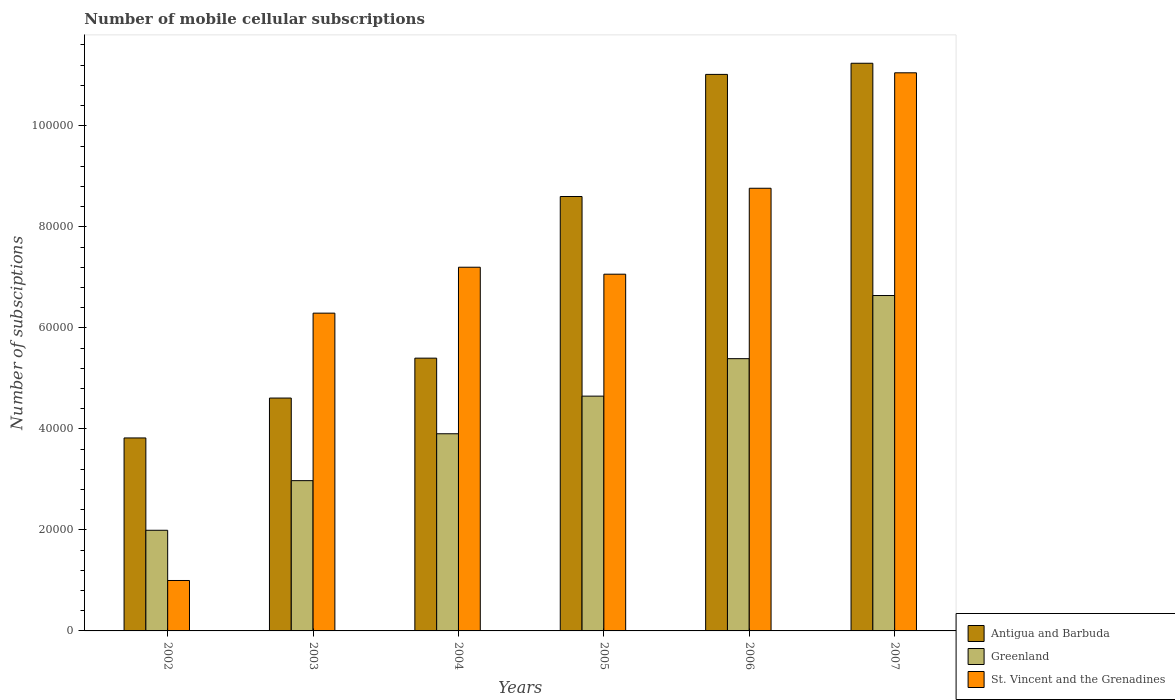How many different coloured bars are there?
Keep it short and to the point. 3. How many bars are there on the 4th tick from the right?
Offer a very short reply. 3. In how many cases, is the number of bars for a given year not equal to the number of legend labels?
Give a very brief answer. 0. What is the number of mobile cellular subscriptions in St. Vincent and the Grenadines in 2005?
Your answer should be very brief. 7.06e+04. Across all years, what is the maximum number of mobile cellular subscriptions in St. Vincent and the Grenadines?
Provide a succinct answer. 1.10e+05. Across all years, what is the minimum number of mobile cellular subscriptions in Greenland?
Your answer should be compact. 1.99e+04. In which year was the number of mobile cellular subscriptions in Antigua and Barbuda maximum?
Your answer should be very brief. 2007. What is the total number of mobile cellular subscriptions in Antigua and Barbuda in the graph?
Offer a very short reply. 4.47e+05. What is the difference between the number of mobile cellular subscriptions in Greenland in 2003 and that in 2004?
Make the answer very short. -9284. What is the difference between the number of mobile cellular subscriptions in Antigua and Barbuda in 2005 and the number of mobile cellular subscriptions in Greenland in 2002?
Offer a terse response. 6.61e+04. What is the average number of mobile cellular subscriptions in St. Vincent and the Grenadines per year?
Provide a succinct answer. 6.89e+04. In the year 2006, what is the difference between the number of mobile cellular subscriptions in St. Vincent and the Grenadines and number of mobile cellular subscriptions in Antigua and Barbuda?
Your answer should be compact. -2.25e+04. In how many years, is the number of mobile cellular subscriptions in St. Vincent and the Grenadines greater than 24000?
Your response must be concise. 5. What is the ratio of the number of mobile cellular subscriptions in St. Vincent and the Grenadines in 2002 to that in 2007?
Your answer should be very brief. 0.09. What is the difference between the highest and the second highest number of mobile cellular subscriptions in Greenland?
Provide a succinct answer. 1.25e+04. What is the difference between the highest and the lowest number of mobile cellular subscriptions in Greenland?
Provide a succinct answer. 4.65e+04. Is the sum of the number of mobile cellular subscriptions in Greenland in 2004 and 2007 greater than the maximum number of mobile cellular subscriptions in Antigua and Barbuda across all years?
Your answer should be compact. No. What does the 2nd bar from the left in 2007 represents?
Offer a terse response. Greenland. What does the 2nd bar from the right in 2004 represents?
Offer a very short reply. Greenland. Is it the case that in every year, the sum of the number of mobile cellular subscriptions in St. Vincent and the Grenadines and number of mobile cellular subscriptions in Antigua and Barbuda is greater than the number of mobile cellular subscriptions in Greenland?
Keep it short and to the point. Yes. Are all the bars in the graph horizontal?
Ensure brevity in your answer.  No. What is the difference between two consecutive major ticks on the Y-axis?
Your response must be concise. 2.00e+04. Are the values on the major ticks of Y-axis written in scientific E-notation?
Your answer should be very brief. No. Does the graph contain grids?
Provide a succinct answer. No. What is the title of the graph?
Your answer should be very brief. Number of mobile cellular subscriptions. Does "Cabo Verde" appear as one of the legend labels in the graph?
Offer a terse response. No. What is the label or title of the X-axis?
Offer a terse response. Years. What is the label or title of the Y-axis?
Keep it short and to the point. Number of subsciptions. What is the Number of subsciptions of Antigua and Barbuda in 2002?
Your answer should be very brief. 3.82e+04. What is the Number of subsciptions of Greenland in 2002?
Provide a short and direct response. 1.99e+04. What is the Number of subsciptions in St. Vincent and the Grenadines in 2002?
Provide a succinct answer. 9982. What is the Number of subsciptions in Antigua and Barbuda in 2003?
Offer a very short reply. 4.61e+04. What is the Number of subsciptions in Greenland in 2003?
Provide a succinct answer. 2.97e+04. What is the Number of subsciptions in St. Vincent and the Grenadines in 2003?
Your answer should be very brief. 6.29e+04. What is the Number of subsciptions in Antigua and Barbuda in 2004?
Make the answer very short. 5.40e+04. What is the Number of subsciptions of Greenland in 2004?
Your response must be concise. 3.90e+04. What is the Number of subsciptions of St. Vincent and the Grenadines in 2004?
Provide a short and direct response. 7.20e+04. What is the Number of subsciptions in Antigua and Barbuda in 2005?
Your answer should be very brief. 8.60e+04. What is the Number of subsciptions of Greenland in 2005?
Give a very brief answer. 4.65e+04. What is the Number of subsciptions in St. Vincent and the Grenadines in 2005?
Provide a succinct answer. 7.06e+04. What is the Number of subsciptions in Antigua and Barbuda in 2006?
Keep it short and to the point. 1.10e+05. What is the Number of subsciptions in Greenland in 2006?
Offer a very short reply. 5.39e+04. What is the Number of subsciptions in St. Vincent and the Grenadines in 2006?
Your answer should be compact. 8.76e+04. What is the Number of subsciptions of Antigua and Barbuda in 2007?
Your response must be concise. 1.12e+05. What is the Number of subsciptions of Greenland in 2007?
Ensure brevity in your answer.  6.64e+04. What is the Number of subsciptions of St. Vincent and the Grenadines in 2007?
Keep it short and to the point. 1.10e+05. Across all years, what is the maximum Number of subsciptions in Antigua and Barbuda?
Keep it short and to the point. 1.12e+05. Across all years, what is the maximum Number of subsciptions in Greenland?
Offer a terse response. 6.64e+04. Across all years, what is the maximum Number of subsciptions in St. Vincent and the Grenadines?
Your response must be concise. 1.10e+05. Across all years, what is the minimum Number of subsciptions in Antigua and Barbuda?
Ensure brevity in your answer.  3.82e+04. Across all years, what is the minimum Number of subsciptions in Greenland?
Offer a terse response. 1.99e+04. Across all years, what is the minimum Number of subsciptions of St. Vincent and the Grenadines?
Provide a succinct answer. 9982. What is the total Number of subsciptions of Antigua and Barbuda in the graph?
Give a very brief answer. 4.47e+05. What is the total Number of subsciptions in Greenland in the graph?
Provide a succinct answer. 2.55e+05. What is the total Number of subsciptions of St. Vincent and the Grenadines in the graph?
Provide a succinct answer. 4.14e+05. What is the difference between the Number of subsciptions in Antigua and Barbuda in 2002 and that in 2003?
Your response must be concise. -7895. What is the difference between the Number of subsciptions of Greenland in 2002 and that in 2003?
Keep it short and to the point. -9825. What is the difference between the Number of subsciptions in St. Vincent and the Grenadines in 2002 and that in 2003?
Give a very brief answer. -5.29e+04. What is the difference between the Number of subsciptions of Antigua and Barbuda in 2002 and that in 2004?
Provide a succinct answer. -1.58e+04. What is the difference between the Number of subsciptions of Greenland in 2002 and that in 2004?
Make the answer very short. -1.91e+04. What is the difference between the Number of subsciptions of St. Vincent and the Grenadines in 2002 and that in 2004?
Make the answer very short. -6.20e+04. What is the difference between the Number of subsciptions in Antigua and Barbuda in 2002 and that in 2005?
Give a very brief answer. -4.78e+04. What is the difference between the Number of subsciptions of Greenland in 2002 and that in 2005?
Provide a short and direct response. -2.66e+04. What is the difference between the Number of subsciptions in St. Vincent and the Grenadines in 2002 and that in 2005?
Make the answer very short. -6.06e+04. What is the difference between the Number of subsciptions in Antigua and Barbuda in 2002 and that in 2006?
Provide a short and direct response. -7.20e+04. What is the difference between the Number of subsciptions of Greenland in 2002 and that in 2006?
Provide a succinct answer. -3.40e+04. What is the difference between the Number of subsciptions of St. Vincent and the Grenadines in 2002 and that in 2006?
Your answer should be very brief. -7.77e+04. What is the difference between the Number of subsciptions in Antigua and Barbuda in 2002 and that in 2007?
Keep it short and to the point. -7.42e+04. What is the difference between the Number of subsciptions of Greenland in 2002 and that in 2007?
Make the answer very short. -4.65e+04. What is the difference between the Number of subsciptions of St. Vincent and the Grenadines in 2002 and that in 2007?
Your response must be concise. -1.01e+05. What is the difference between the Number of subsciptions in Antigua and Barbuda in 2003 and that in 2004?
Your answer should be very brief. -7900. What is the difference between the Number of subsciptions in Greenland in 2003 and that in 2004?
Your response must be concise. -9284. What is the difference between the Number of subsciptions in St. Vincent and the Grenadines in 2003 and that in 2004?
Your response must be concise. -9089. What is the difference between the Number of subsciptions in Antigua and Barbuda in 2003 and that in 2005?
Offer a very short reply. -3.99e+04. What is the difference between the Number of subsciptions of Greenland in 2003 and that in 2005?
Keep it short and to the point. -1.67e+04. What is the difference between the Number of subsciptions in St. Vincent and the Grenadines in 2003 and that in 2005?
Your answer should be compact. -7709. What is the difference between the Number of subsciptions in Antigua and Barbuda in 2003 and that in 2006?
Provide a short and direct response. -6.41e+04. What is the difference between the Number of subsciptions in Greenland in 2003 and that in 2006?
Your response must be concise. -2.42e+04. What is the difference between the Number of subsciptions of St. Vincent and the Grenadines in 2003 and that in 2006?
Your answer should be very brief. -2.47e+04. What is the difference between the Number of subsciptions in Antigua and Barbuda in 2003 and that in 2007?
Keep it short and to the point. -6.63e+04. What is the difference between the Number of subsciptions in Greenland in 2003 and that in 2007?
Your answer should be very brief. -3.67e+04. What is the difference between the Number of subsciptions in St. Vincent and the Grenadines in 2003 and that in 2007?
Offer a terse response. -4.76e+04. What is the difference between the Number of subsciptions of Antigua and Barbuda in 2004 and that in 2005?
Ensure brevity in your answer.  -3.20e+04. What is the difference between the Number of subsciptions in Greenland in 2004 and that in 2005?
Offer a very short reply. -7447. What is the difference between the Number of subsciptions of St. Vincent and the Grenadines in 2004 and that in 2005?
Give a very brief answer. 1380. What is the difference between the Number of subsciptions of Antigua and Barbuda in 2004 and that in 2006?
Your response must be concise. -5.62e+04. What is the difference between the Number of subsciptions in Greenland in 2004 and that in 2006?
Provide a short and direct response. -1.49e+04. What is the difference between the Number of subsciptions in St. Vincent and the Grenadines in 2004 and that in 2006?
Ensure brevity in your answer.  -1.56e+04. What is the difference between the Number of subsciptions in Antigua and Barbuda in 2004 and that in 2007?
Give a very brief answer. -5.84e+04. What is the difference between the Number of subsciptions in Greenland in 2004 and that in 2007?
Your answer should be compact. -2.74e+04. What is the difference between the Number of subsciptions in St. Vincent and the Grenadines in 2004 and that in 2007?
Keep it short and to the point. -3.85e+04. What is the difference between the Number of subsciptions in Antigua and Barbuda in 2005 and that in 2006?
Your response must be concise. -2.42e+04. What is the difference between the Number of subsciptions in Greenland in 2005 and that in 2006?
Give a very brief answer. -7420. What is the difference between the Number of subsciptions in St. Vincent and the Grenadines in 2005 and that in 2006?
Your response must be concise. -1.70e+04. What is the difference between the Number of subsciptions of Antigua and Barbuda in 2005 and that in 2007?
Provide a succinct answer. -2.64e+04. What is the difference between the Number of subsciptions of Greenland in 2005 and that in 2007?
Offer a terse response. -1.99e+04. What is the difference between the Number of subsciptions of St. Vincent and the Grenadines in 2005 and that in 2007?
Give a very brief answer. -3.99e+04. What is the difference between the Number of subsciptions in Antigua and Barbuda in 2006 and that in 2007?
Your answer should be compact. -2204. What is the difference between the Number of subsciptions of Greenland in 2006 and that in 2007?
Make the answer very short. -1.25e+04. What is the difference between the Number of subsciptions of St. Vincent and the Grenadines in 2006 and that in 2007?
Provide a short and direct response. -2.29e+04. What is the difference between the Number of subsciptions in Antigua and Barbuda in 2002 and the Number of subsciptions in Greenland in 2003?
Provide a short and direct response. 8456. What is the difference between the Number of subsciptions in Antigua and Barbuda in 2002 and the Number of subsciptions in St. Vincent and the Grenadines in 2003?
Provide a succinct answer. -2.47e+04. What is the difference between the Number of subsciptions of Greenland in 2002 and the Number of subsciptions of St. Vincent and the Grenadines in 2003?
Offer a terse response. -4.30e+04. What is the difference between the Number of subsciptions of Antigua and Barbuda in 2002 and the Number of subsciptions of Greenland in 2004?
Your response must be concise. -828. What is the difference between the Number of subsciptions of Antigua and Barbuda in 2002 and the Number of subsciptions of St. Vincent and the Grenadines in 2004?
Offer a terse response. -3.38e+04. What is the difference between the Number of subsciptions of Greenland in 2002 and the Number of subsciptions of St. Vincent and the Grenadines in 2004?
Your response must be concise. -5.21e+04. What is the difference between the Number of subsciptions of Antigua and Barbuda in 2002 and the Number of subsciptions of Greenland in 2005?
Provide a succinct answer. -8275. What is the difference between the Number of subsciptions in Antigua and Barbuda in 2002 and the Number of subsciptions in St. Vincent and the Grenadines in 2005?
Offer a terse response. -3.24e+04. What is the difference between the Number of subsciptions in Greenland in 2002 and the Number of subsciptions in St. Vincent and the Grenadines in 2005?
Provide a succinct answer. -5.07e+04. What is the difference between the Number of subsciptions in Antigua and Barbuda in 2002 and the Number of subsciptions in Greenland in 2006?
Offer a very short reply. -1.57e+04. What is the difference between the Number of subsciptions in Antigua and Barbuda in 2002 and the Number of subsciptions in St. Vincent and the Grenadines in 2006?
Offer a very short reply. -4.94e+04. What is the difference between the Number of subsciptions of Greenland in 2002 and the Number of subsciptions of St. Vincent and the Grenadines in 2006?
Make the answer very short. -6.77e+04. What is the difference between the Number of subsciptions in Antigua and Barbuda in 2002 and the Number of subsciptions in Greenland in 2007?
Ensure brevity in your answer.  -2.82e+04. What is the difference between the Number of subsciptions in Antigua and Barbuda in 2002 and the Number of subsciptions in St. Vincent and the Grenadines in 2007?
Ensure brevity in your answer.  -7.23e+04. What is the difference between the Number of subsciptions in Greenland in 2002 and the Number of subsciptions in St. Vincent and the Grenadines in 2007?
Ensure brevity in your answer.  -9.06e+04. What is the difference between the Number of subsciptions of Antigua and Barbuda in 2003 and the Number of subsciptions of Greenland in 2004?
Ensure brevity in your answer.  7067. What is the difference between the Number of subsciptions of Antigua and Barbuda in 2003 and the Number of subsciptions of St. Vincent and the Grenadines in 2004?
Offer a terse response. -2.59e+04. What is the difference between the Number of subsciptions in Greenland in 2003 and the Number of subsciptions in St. Vincent and the Grenadines in 2004?
Provide a short and direct response. -4.23e+04. What is the difference between the Number of subsciptions of Antigua and Barbuda in 2003 and the Number of subsciptions of Greenland in 2005?
Offer a terse response. -380. What is the difference between the Number of subsciptions in Antigua and Barbuda in 2003 and the Number of subsciptions in St. Vincent and the Grenadines in 2005?
Your response must be concise. -2.45e+04. What is the difference between the Number of subsciptions of Greenland in 2003 and the Number of subsciptions of St. Vincent and the Grenadines in 2005?
Your answer should be very brief. -4.09e+04. What is the difference between the Number of subsciptions of Antigua and Barbuda in 2003 and the Number of subsciptions of Greenland in 2006?
Keep it short and to the point. -7800. What is the difference between the Number of subsciptions in Antigua and Barbuda in 2003 and the Number of subsciptions in St. Vincent and the Grenadines in 2006?
Your response must be concise. -4.15e+04. What is the difference between the Number of subsciptions of Greenland in 2003 and the Number of subsciptions of St. Vincent and the Grenadines in 2006?
Make the answer very short. -5.79e+04. What is the difference between the Number of subsciptions in Antigua and Barbuda in 2003 and the Number of subsciptions in Greenland in 2007?
Ensure brevity in your answer.  -2.03e+04. What is the difference between the Number of subsciptions in Antigua and Barbuda in 2003 and the Number of subsciptions in St. Vincent and the Grenadines in 2007?
Give a very brief answer. -6.44e+04. What is the difference between the Number of subsciptions of Greenland in 2003 and the Number of subsciptions of St. Vincent and the Grenadines in 2007?
Give a very brief answer. -8.07e+04. What is the difference between the Number of subsciptions in Antigua and Barbuda in 2004 and the Number of subsciptions in Greenland in 2005?
Offer a very short reply. 7520. What is the difference between the Number of subsciptions of Antigua and Barbuda in 2004 and the Number of subsciptions of St. Vincent and the Grenadines in 2005?
Make the answer very short. -1.66e+04. What is the difference between the Number of subsciptions of Greenland in 2004 and the Number of subsciptions of St. Vincent and the Grenadines in 2005?
Keep it short and to the point. -3.16e+04. What is the difference between the Number of subsciptions of Antigua and Barbuda in 2004 and the Number of subsciptions of Greenland in 2006?
Make the answer very short. 100. What is the difference between the Number of subsciptions in Antigua and Barbuda in 2004 and the Number of subsciptions in St. Vincent and the Grenadines in 2006?
Your answer should be very brief. -3.36e+04. What is the difference between the Number of subsciptions of Greenland in 2004 and the Number of subsciptions of St. Vincent and the Grenadines in 2006?
Your answer should be compact. -4.86e+04. What is the difference between the Number of subsciptions of Antigua and Barbuda in 2004 and the Number of subsciptions of Greenland in 2007?
Give a very brief answer. -1.24e+04. What is the difference between the Number of subsciptions of Antigua and Barbuda in 2004 and the Number of subsciptions of St. Vincent and the Grenadines in 2007?
Your answer should be very brief. -5.65e+04. What is the difference between the Number of subsciptions of Greenland in 2004 and the Number of subsciptions of St. Vincent and the Grenadines in 2007?
Your answer should be compact. -7.15e+04. What is the difference between the Number of subsciptions of Antigua and Barbuda in 2005 and the Number of subsciptions of Greenland in 2006?
Ensure brevity in your answer.  3.21e+04. What is the difference between the Number of subsciptions of Antigua and Barbuda in 2005 and the Number of subsciptions of St. Vincent and the Grenadines in 2006?
Ensure brevity in your answer.  -1634. What is the difference between the Number of subsciptions of Greenland in 2005 and the Number of subsciptions of St. Vincent and the Grenadines in 2006?
Your answer should be compact. -4.12e+04. What is the difference between the Number of subsciptions in Antigua and Barbuda in 2005 and the Number of subsciptions in Greenland in 2007?
Give a very brief answer. 1.96e+04. What is the difference between the Number of subsciptions of Antigua and Barbuda in 2005 and the Number of subsciptions of St. Vincent and the Grenadines in 2007?
Ensure brevity in your answer.  -2.45e+04. What is the difference between the Number of subsciptions in Greenland in 2005 and the Number of subsciptions in St. Vincent and the Grenadines in 2007?
Offer a terse response. -6.40e+04. What is the difference between the Number of subsciptions in Antigua and Barbuda in 2006 and the Number of subsciptions in Greenland in 2007?
Offer a terse response. 4.38e+04. What is the difference between the Number of subsciptions in Antigua and Barbuda in 2006 and the Number of subsciptions in St. Vincent and the Grenadines in 2007?
Give a very brief answer. -314. What is the difference between the Number of subsciptions of Greenland in 2006 and the Number of subsciptions of St. Vincent and the Grenadines in 2007?
Provide a short and direct response. -5.66e+04. What is the average Number of subsciptions in Antigua and Barbuda per year?
Make the answer very short. 7.45e+04. What is the average Number of subsciptions of Greenland per year?
Keep it short and to the point. 4.26e+04. What is the average Number of subsciptions in St. Vincent and the Grenadines per year?
Offer a terse response. 6.89e+04. In the year 2002, what is the difference between the Number of subsciptions in Antigua and Barbuda and Number of subsciptions in Greenland?
Provide a succinct answer. 1.83e+04. In the year 2002, what is the difference between the Number of subsciptions in Antigua and Barbuda and Number of subsciptions in St. Vincent and the Grenadines?
Give a very brief answer. 2.82e+04. In the year 2002, what is the difference between the Number of subsciptions in Greenland and Number of subsciptions in St. Vincent and the Grenadines?
Your answer should be very brief. 9942. In the year 2003, what is the difference between the Number of subsciptions in Antigua and Barbuda and Number of subsciptions in Greenland?
Provide a succinct answer. 1.64e+04. In the year 2003, what is the difference between the Number of subsciptions of Antigua and Barbuda and Number of subsciptions of St. Vincent and the Grenadines?
Your response must be concise. -1.68e+04. In the year 2003, what is the difference between the Number of subsciptions in Greenland and Number of subsciptions in St. Vincent and the Grenadines?
Give a very brief answer. -3.32e+04. In the year 2004, what is the difference between the Number of subsciptions of Antigua and Barbuda and Number of subsciptions of Greenland?
Offer a very short reply. 1.50e+04. In the year 2004, what is the difference between the Number of subsciptions in Antigua and Barbuda and Number of subsciptions in St. Vincent and the Grenadines?
Your response must be concise. -1.80e+04. In the year 2004, what is the difference between the Number of subsciptions of Greenland and Number of subsciptions of St. Vincent and the Grenadines?
Offer a very short reply. -3.30e+04. In the year 2005, what is the difference between the Number of subsciptions of Antigua and Barbuda and Number of subsciptions of Greenland?
Provide a short and direct response. 3.95e+04. In the year 2005, what is the difference between the Number of subsciptions of Antigua and Barbuda and Number of subsciptions of St. Vincent and the Grenadines?
Provide a succinct answer. 1.54e+04. In the year 2005, what is the difference between the Number of subsciptions in Greenland and Number of subsciptions in St. Vincent and the Grenadines?
Offer a terse response. -2.41e+04. In the year 2006, what is the difference between the Number of subsciptions of Antigua and Barbuda and Number of subsciptions of Greenland?
Your answer should be very brief. 5.63e+04. In the year 2006, what is the difference between the Number of subsciptions of Antigua and Barbuda and Number of subsciptions of St. Vincent and the Grenadines?
Keep it short and to the point. 2.25e+04. In the year 2006, what is the difference between the Number of subsciptions of Greenland and Number of subsciptions of St. Vincent and the Grenadines?
Provide a short and direct response. -3.37e+04. In the year 2007, what is the difference between the Number of subsciptions in Antigua and Barbuda and Number of subsciptions in Greenland?
Keep it short and to the point. 4.60e+04. In the year 2007, what is the difference between the Number of subsciptions of Antigua and Barbuda and Number of subsciptions of St. Vincent and the Grenadines?
Give a very brief answer. 1890. In the year 2007, what is the difference between the Number of subsciptions in Greenland and Number of subsciptions in St. Vincent and the Grenadines?
Give a very brief answer. -4.41e+04. What is the ratio of the Number of subsciptions of Antigua and Barbuda in 2002 to that in 2003?
Your answer should be compact. 0.83. What is the ratio of the Number of subsciptions in Greenland in 2002 to that in 2003?
Make the answer very short. 0.67. What is the ratio of the Number of subsciptions of St. Vincent and the Grenadines in 2002 to that in 2003?
Provide a short and direct response. 0.16. What is the ratio of the Number of subsciptions in Antigua and Barbuda in 2002 to that in 2004?
Offer a terse response. 0.71. What is the ratio of the Number of subsciptions of Greenland in 2002 to that in 2004?
Ensure brevity in your answer.  0.51. What is the ratio of the Number of subsciptions of St. Vincent and the Grenadines in 2002 to that in 2004?
Your answer should be compact. 0.14. What is the ratio of the Number of subsciptions in Antigua and Barbuda in 2002 to that in 2005?
Offer a very short reply. 0.44. What is the ratio of the Number of subsciptions of Greenland in 2002 to that in 2005?
Make the answer very short. 0.43. What is the ratio of the Number of subsciptions of St. Vincent and the Grenadines in 2002 to that in 2005?
Make the answer very short. 0.14. What is the ratio of the Number of subsciptions in Antigua and Barbuda in 2002 to that in 2006?
Offer a very short reply. 0.35. What is the ratio of the Number of subsciptions of Greenland in 2002 to that in 2006?
Offer a terse response. 0.37. What is the ratio of the Number of subsciptions of St. Vincent and the Grenadines in 2002 to that in 2006?
Keep it short and to the point. 0.11. What is the ratio of the Number of subsciptions in Antigua and Barbuda in 2002 to that in 2007?
Ensure brevity in your answer.  0.34. What is the ratio of the Number of subsciptions of Greenland in 2002 to that in 2007?
Keep it short and to the point. 0.3. What is the ratio of the Number of subsciptions in St. Vincent and the Grenadines in 2002 to that in 2007?
Your answer should be compact. 0.09. What is the ratio of the Number of subsciptions of Antigua and Barbuda in 2003 to that in 2004?
Make the answer very short. 0.85. What is the ratio of the Number of subsciptions in Greenland in 2003 to that in 2004?
Offer a terse response. 0.76. What is the ratio of the Number of subsciptions in St. Vincent and the Grenadines in 2003 to that in 2004?
Provide a succinct answer. 0.87. What is the ratio of the Number of subsciptions of Antigua and Barbuda in 2003 to that in 2005?
Ensure brevity in your answer.  0.54. What is the ratio of the Number of subsciptions of Greenland in 2003 to that in 2005?
Give a very brief answer. 0.64. What is the ratio of the Number of subsciptions of St. Vincent and the Grenadines in 2003 to that in 2005?
Your answer should be compact. 0.89. What is the ratio of the Number of subsciptions in Antigua and Barbuda in 2003 to that in 2006?
Ensure brevity in your answer.  0.42. What is the ratio of the Number of subsciptions of Greenland in 2003 to that in 2006?
Your response must be concise. 0.55. What is the ratio of the Number of subsciptions of St. Vincent and the Grenadines in 2003 to that in 2006?
Your answer should be compact. 0.72. What is the ratio of the Number of subsciptions of Antigua and Barbuda in 2003 to that in 2007?
Your answer should be very brief. 0.41. What is the ratio of the Number of subsciptions of Greenland in 2003 to that in 2007?
Your answer should be compact. 0.45. What is the ratio of the Number of subsciptions of St. Vincent and the Grenadines in 2003 to that in 2007?
Provide a short and direct response. 0.57. What is the ratio of the Number of subsciptions in Antigua and Barbuda in 2004 to that in 2005?
Ensure brevity in your answer.  0.63. What is the ratio of the Number of subsciptions of Greenland in 2004 to that in 2005?
Your answer should be compact. 0.84. What is the ratio of the Number of subsciptions in St. Vincent and the Grenadines in 2004 to that in 2005?
Ensure brevity in your answer.  1.02. What is the ratio of the Number of subsciptions of Antigua and Barbuda in 2004 to that in 2006?
Your answer should be compact. 0.49. What is the ratio of the Number of subsciptions of Greenland in 2004 to that in 2006?
Offer a terse response. 0.72. What is the ratio of the Number of subsciptions in St. Vincent and the Grenadines in 2004 to that in 2006?
Offer a very short reply. 0.82. What is the ratio of the Number of subsciptions of Antigua and Barbuda in 2004 to that in 2007?
Offer a terse response. 0.48. What is the ratio of the Number of subsciptions in Greenland in 2004 to that in 2007?
Provide a short and direct response. 0.59. What is the ratio of the Number of subsciptions of St. Vincent and the Grenadines in 2004 to that in 2007?
Your answer should be very brief. 0.65. What is the ratio of the Number of subsciptions in Antigua and Barbuda in 2005 to that in 2006?
Your response must be concise. 0.78. What is the ratio of the Number of subsciptions of Greenland in 2005 to that in 2006?
Keep it short and to the point. 0.86. What is the ratio of the Number of subsciptions of St. Vincent and the Grenadines in 2005 to that in 2006?
Offer a terse response. 0.81. What is the ratio of the Number of subsciptions of Antigua and Barbuda in 2005 to that in 2007?
Provide a short and direct response. 0.77. What is the ratio of the Number of subsciptions in St. Vincent and the Grenadines in 2005 to that in 2007?
Provide a short and direct response. 0.64. What is the ratio of the Number of subsciptions of Antigua and Barbuda in 2006 to that in 2007?
Provide a short and direct response. 0.98. What is the ratio of the Number of subsciptions in Greenland in 2006 to that in 2007?
Provide a short and direct response. 0.81. What is the ratio of the Number of subsciptions of St. Vincent and the Grenadines in 2006 to that in 2007?
Your answer should be compact. 0.79. What is the difference between the highest and the second highest Number of subsciptions in Antigua and Barbuda?
Provide a succinct answer. 2204. What is the difference between the highest and the second highest Number of subsciptions of Greenland?
Ensure brevity in your answer.  1.25e+04. What is the difference between the highest and the second highest Number of subsciptions in St. Vincent and the Grenadines?
Keep it short and to the point. 2.29e+04. What is the difference between the highest and the lowest Number of subsciptions in Antigua and Barbuda?
Your answer should be compact. 7.42e+04. What is the difference between the highest and the lowest Number of subsciptions in Greenland?
Make the answer very short. 4.65e+04. What is the difference between the highest and the lowest Number of subsciptions in St. Vincent and the Grenadines?
Make the answer very short. 1.01e+05. 